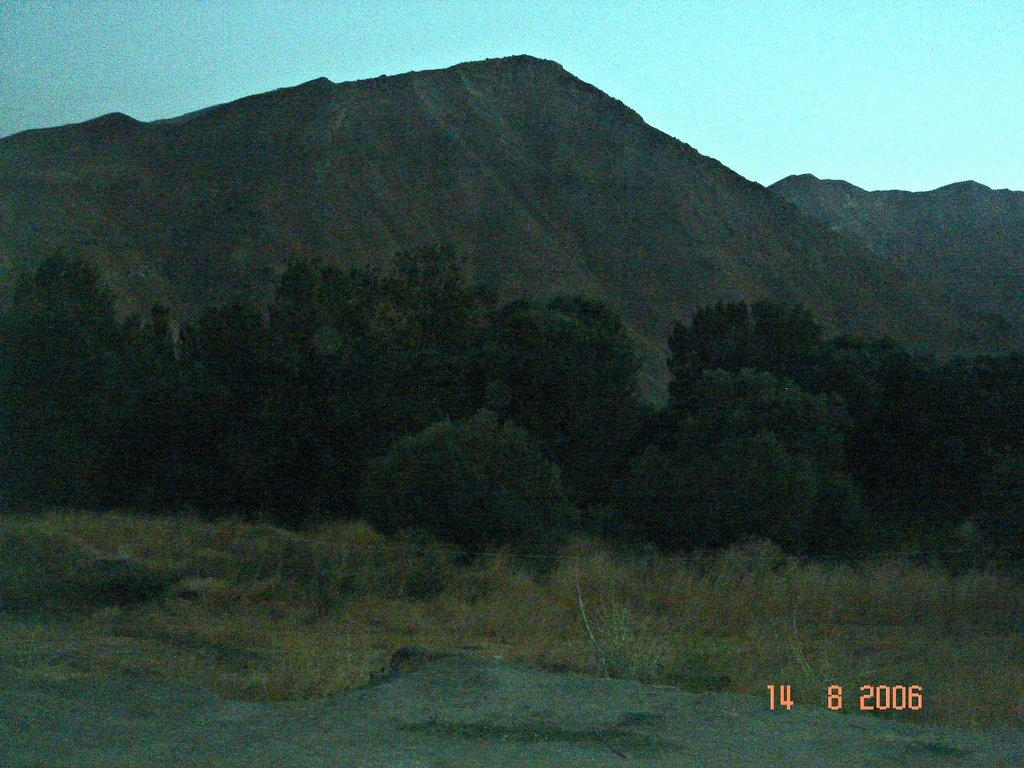What type of vegetation is present in the image? There is a bunch of trees in the image. What is covering the ground in the image? There is grass on the ground in the image. What type of landscape feature can be seen in the image? There are hills visible in the image. What is the color and condition of the sky in the image? The sky is blue and cloudy in the image. Can you see any skates floating in the sky in the image? There are no skates visible in the image; it features a bunch of trees, grass, hills, and a blue, cloudy sky. Are there any bubbles forming around the trees in the image? There are no bubbles present in the image. 